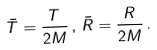Convert formula to latex. <formula><loc_0><loc_0><loc_500><loc_500>\bar { T } = \frac { T } { 2 M } \, , \, \bar { R } = \frac { R } { 2 M } \, .</formula> 